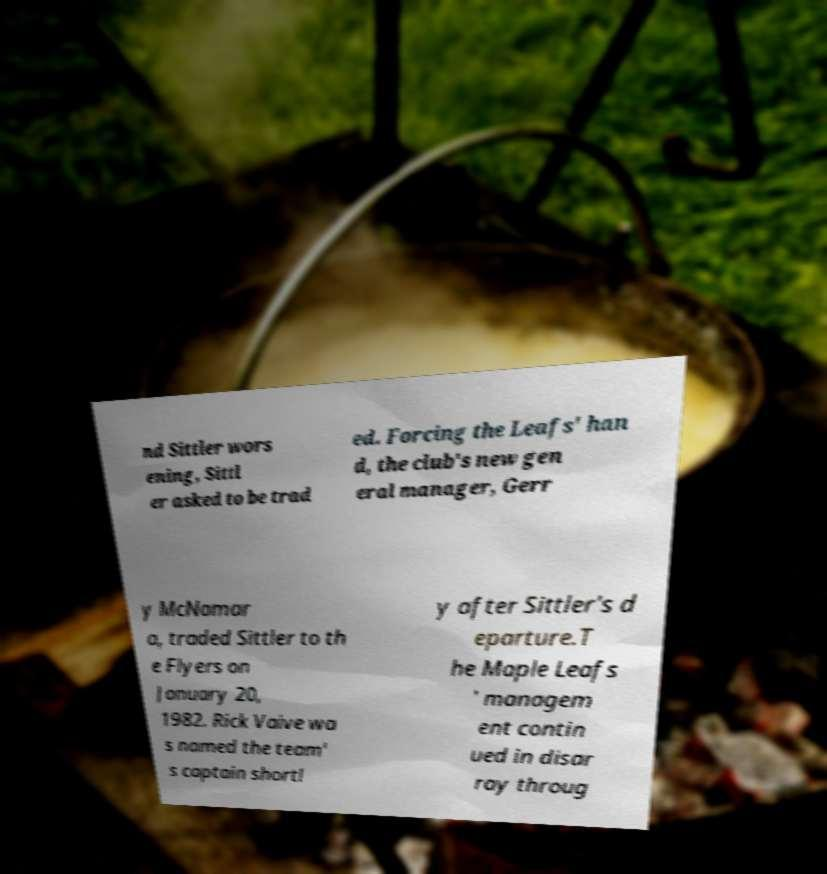Could you extract and type out the text from this image? nd Sittler wors ening, Sittl er asked to be trad ed. Forcing the Leafs' han d, the club's new gen eral manager, Gerr y McNamar a, traded Sittler to th e Flyers on January 20, 1982. Rick Vaive wa s named the team' s captain shortl y after Sittler's d eparture.T he Maple Leafs ' managem ent contin ued in disar ray throug 